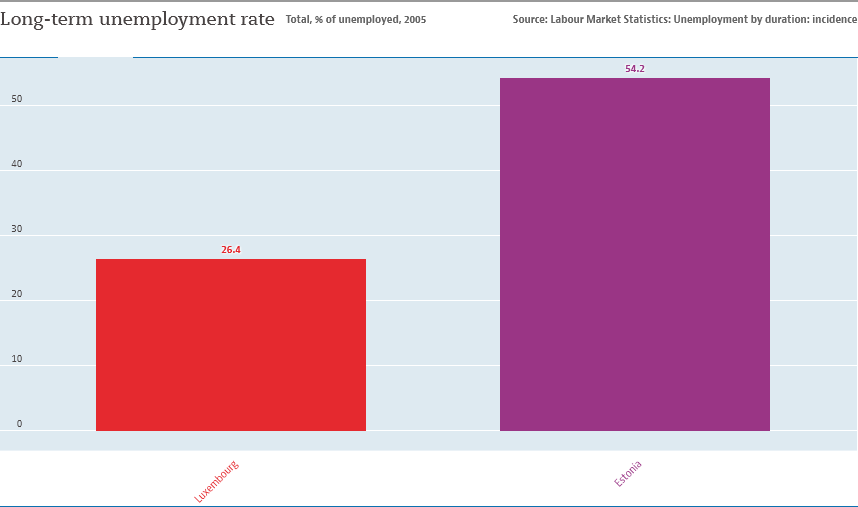Identify some key points in this picture. The ratio of two bars is 0.48708... The larger purple bar is purple. 